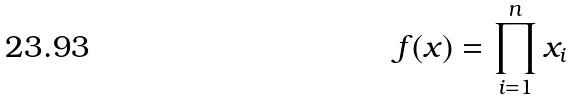<formula> <loc_0><loc_0><loc_500><loc_500>f ( x ) = \prod _ { i = 1 } ^ { n } x _ { i }</formula> 